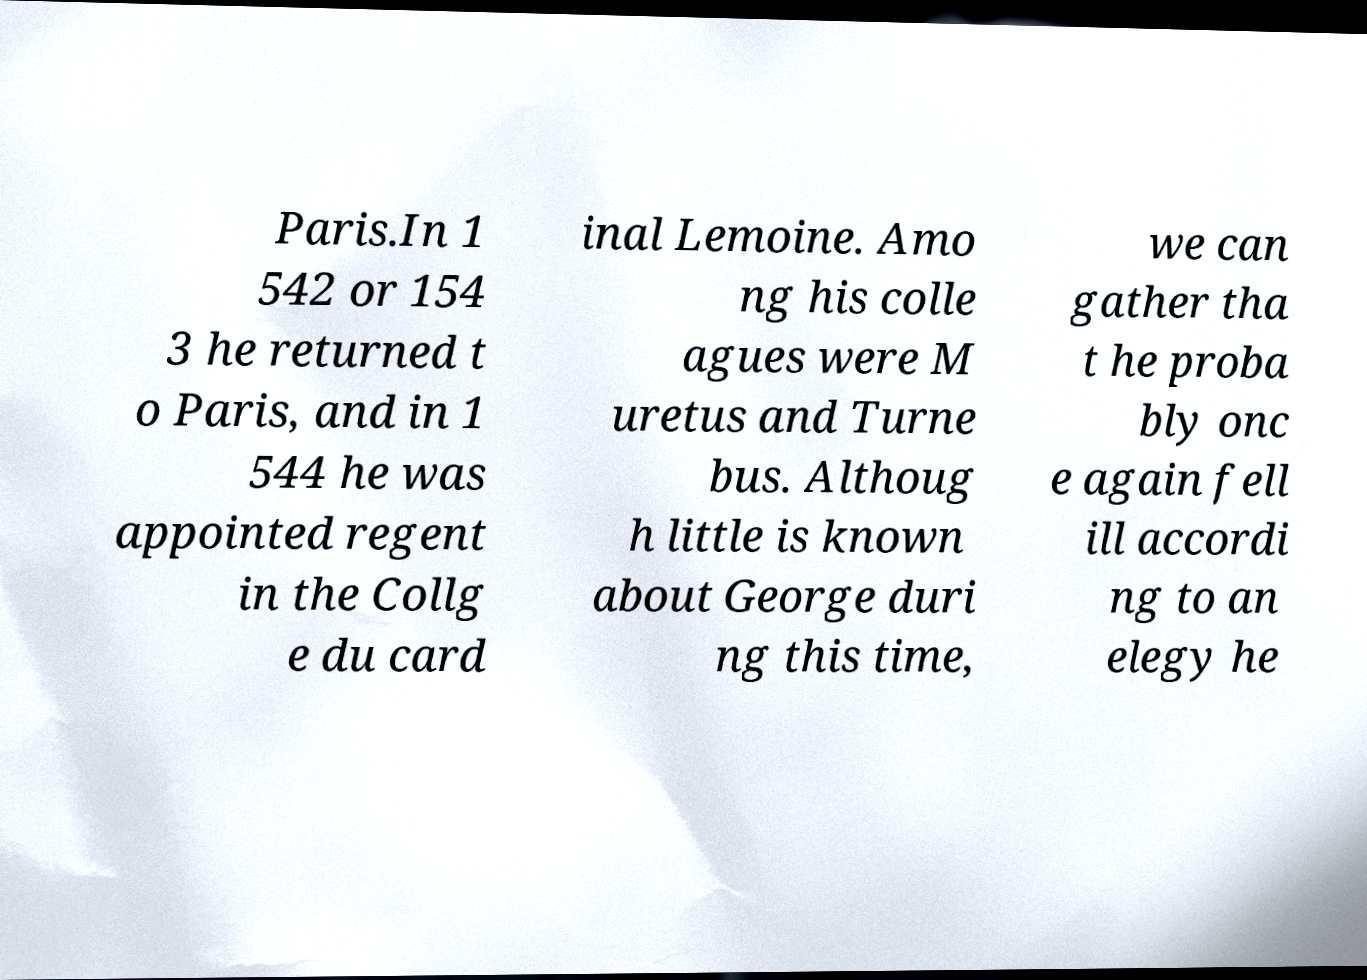There's text embedded in this image that I need extracted. Can you transcribe it verbatim? Paris.In 1 542 or 154 3 he returned t o Paris, and in 1 544 he was appointed regent in the Collg e du card inal Lemoine. Amo ng his colle agues were M uretus and Turne bus. Althoug h little is known about George duri ng this time, we can gather tha t he proba bly onc e again fell ill accordi ng to an elegy he 